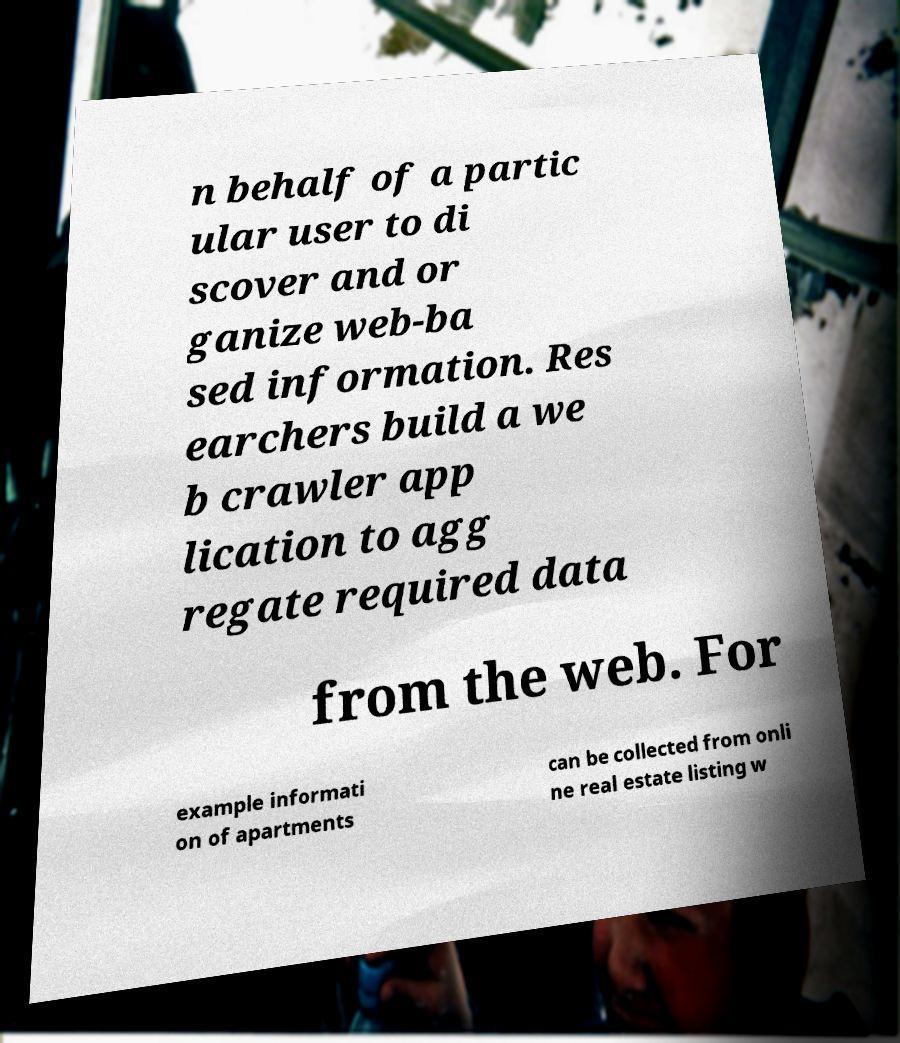Can you accurately transcribe the text from the provided image for me? n behalf of a partic ular user to di scover and or ganize web-ba sed information. Res earchers build a we b crawler app lication to agg regate required data from the web. For example informati on of apartments can be collected from onli ne real estate listing w 